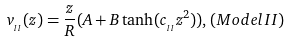<formula> <loc_0><loc_0><loc_500><loc_500>v _ { _ { I I } } ( z ) = \frac { z } { R } ( A + B \tanh ( c _ { _ { I I } } z ^ { 2 } ) ) , ( M o d e l I I )</formula> 